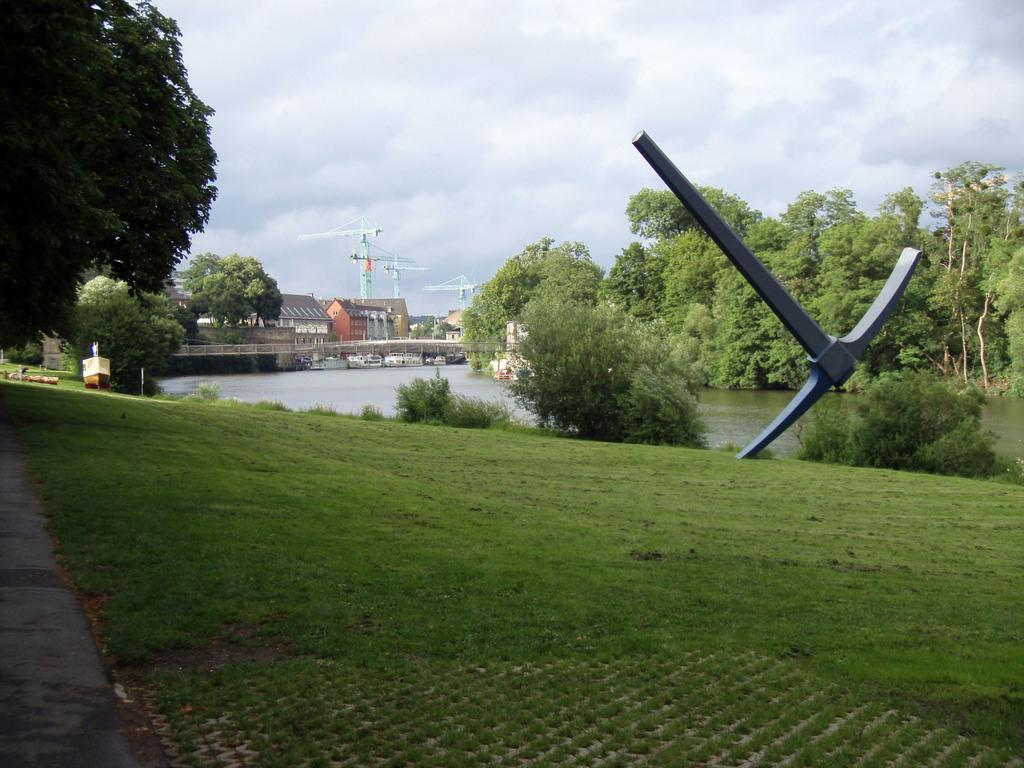What type of buildings can be seen in the image? There are houses in the image. What type of man-made structure is present in the image? There is a bridge in the image. What type of vegetation is visible in the image? There are trees, plants, and grass in the image. What type of path is present in the image? There is a path in the image. What type of water feature is visible in the image? There is water visible in the image. What type of structure is present in the image? There is a structure in the image. What is visible in the sky in the image? The sky is visible in the image, and there are clouds in the sky. What type of construction equipment is present in the image? There are cranes in the image. What is the rate of the church's growth in the image? There is no church present in the image, so it is not possible to determine its growth rate. What type of drug is being administered to the plants in the image? There is no drug present in the image, and the plants do not appear to be receiving any treatment. 